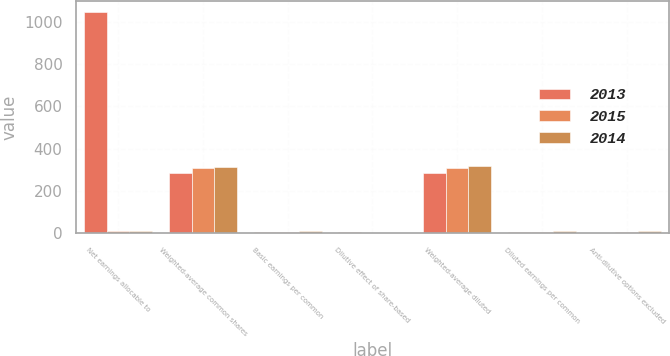<chart> <loc_0><loc_0><loc_500><loc_500><stacked_bar_chart><ecel><fcel>Net earnings allocable to<fcel>Weighted-average common shares<fcel>Basic earnings per common<fcel>Dilutive effect of share-based<fcel>Weighted-average diluted<fcel>Diluted earnings per common<fcel>Anti-dilutive options excluded<nl><fcel>2013<fcel>1048<fcel>283<fcel>3.7<fcel>4<fcel>287<fcel>3.65<fcel>2.1<nl><fcel>2015<fcel>8.55<fcel>307<fcel>7.56<fcel>3<fcel>310<fcel>7.48<fcel>3.3<nl><fcel>2014<fcel>8.55<fcel>315<fcel>8.61<fcel>2<fcel>317<fcel>8.55<fcel>11.1<nl></chart> 